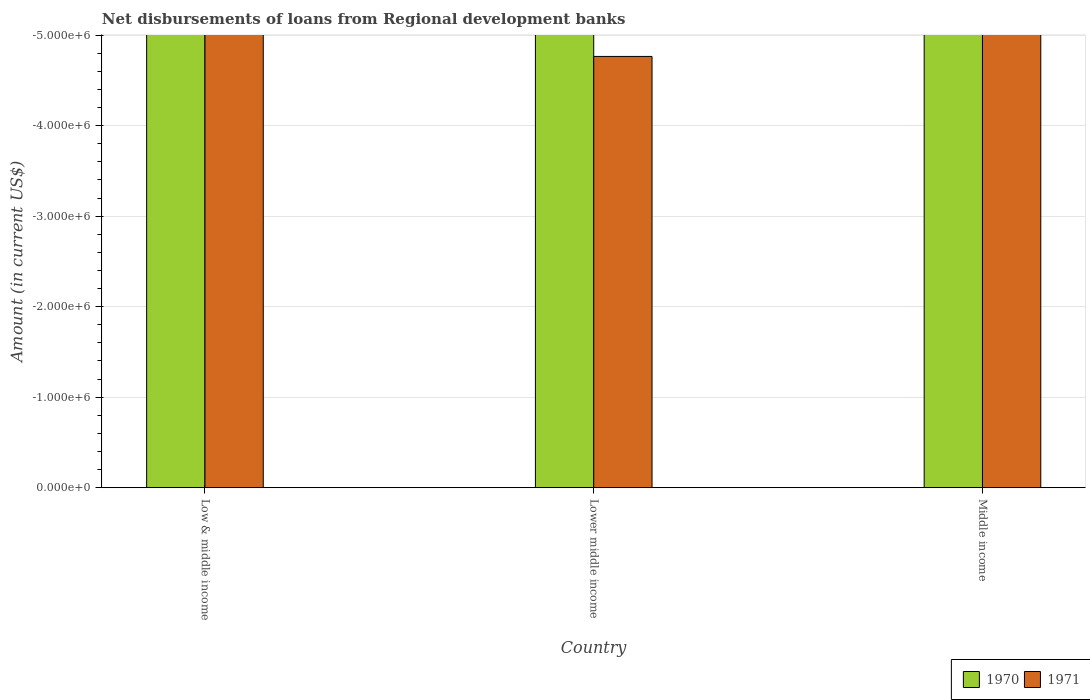How many bars are there on the 1st tick from the right?
Your answer should be compact. 0. What is the label of the 1st group of bars from the left?
Your response must be concise. Low & middle income. What is the amount of disbursements of loans from regional development banks in 1970 in Middle income?
Offer a terse response. 0. What is the total amount of disbursements of loans from regional development banks in 1970 in the graph?
Offer a terse response. 0. What is the difference between the amount of disbursements of loans from regional development banks in 1971 in Lower middle income and the amount of disbursements of loans from regional development banks in 1970 in Low & middle income?
Keep it short and to the point. 0. What is the average amount of disbursements of loans from regional development banks in 1971 per country?
Offer a terse response. 0. In how many countries, is the amount of disbursements of loans from regional development banks in 1970 greater than -1000000 US$?
Make the answer very short. 0. What is the difference between two consecutive major ticks on the Y-axis?
Your answer should be compact. 1.00e+06. How many legend labels are there?
Give a very brief answer. 2. How are the legend labels stacked?
Give a very brief answer. Horizontal. What is the title of the graph?
Your answer should be compact. Net disbursements of loans from Regional development banks. Does "1978" appear as one of the legend labels in the graph?
Ensure brevity in your answer.  No. What is the Amount (in current US$) of 1971 in Low & middle income?
Provide a short and direct response. 0. What is the Amount (in current US$) of 1970 in Lower middle income?
Provide a succinct answer. 0. What is the Amount (in current US$) in 1971 in Lower middle income?
Provide a succinct answer. 0. What is the Amount (in current US$) in 1970 in Middle income?
Your answer should be compact. 0. What is the Amount (in current US$) of 1971 in Middle income?
Your answer should be compact. 0. What is the average Amount (in current US$) of 1970 per country?
Offer a terse response. 0. What is the average Amount (in current US$) in 1971 per country?
Keep it short and to the point. 0. 